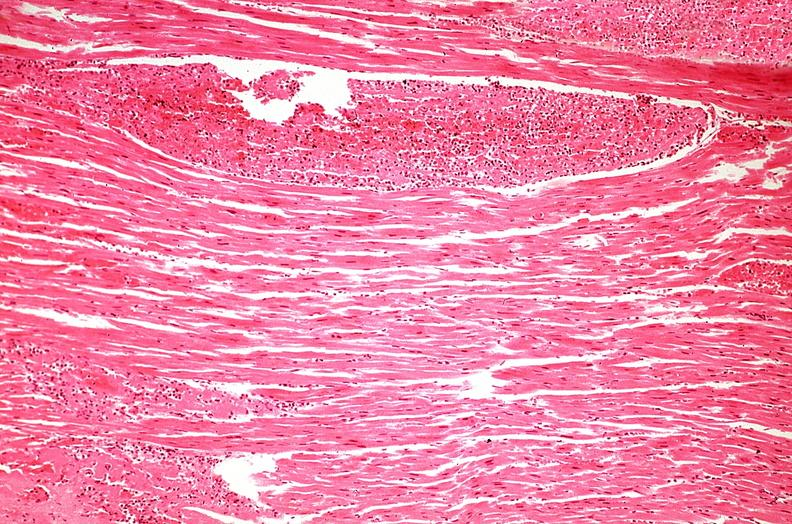s cardiovascular present?
Answer the question using a single word or phrase. Yes 